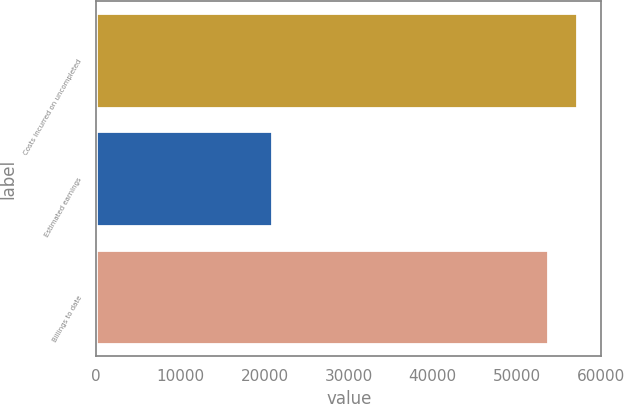Convert chart. <chart><loc_0><loc_0><loc_500><loc_500><bar_chart><fcel>Costs incurred on uncompleted<fcel>Estimated earnings<fcel>Billings to date<nl><fcel>57154.6<fcel>20883<fcel>53708<nl></chart> 